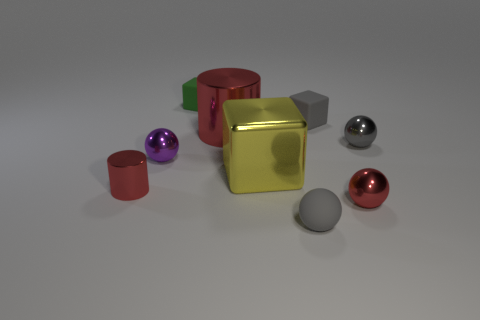Subtract all gray shiny balls. How many balls are left? 3 Subtract all blue cylinders. How many gray balls are left? 2 Add 1 purple cubes. How many objects exist? 10 Subtract 1 cubes. How many cubes are left? 2 Subtract all purple spheres. How many spheres are left? 3 Subtract all spheres. How many objects are left? 5 Subtract all tiny gray spheres. Subtract all purple balls. How many objects are left? 6 Add 1 rubber balls. How many rubber balls are left? 2 Add 8 small metal cylinders. How many small metal cylinders exist? 9 Subtract 0 blue blocks. How many objects are left? 9 